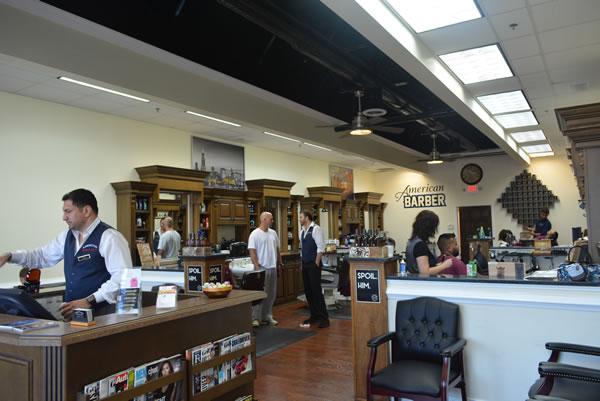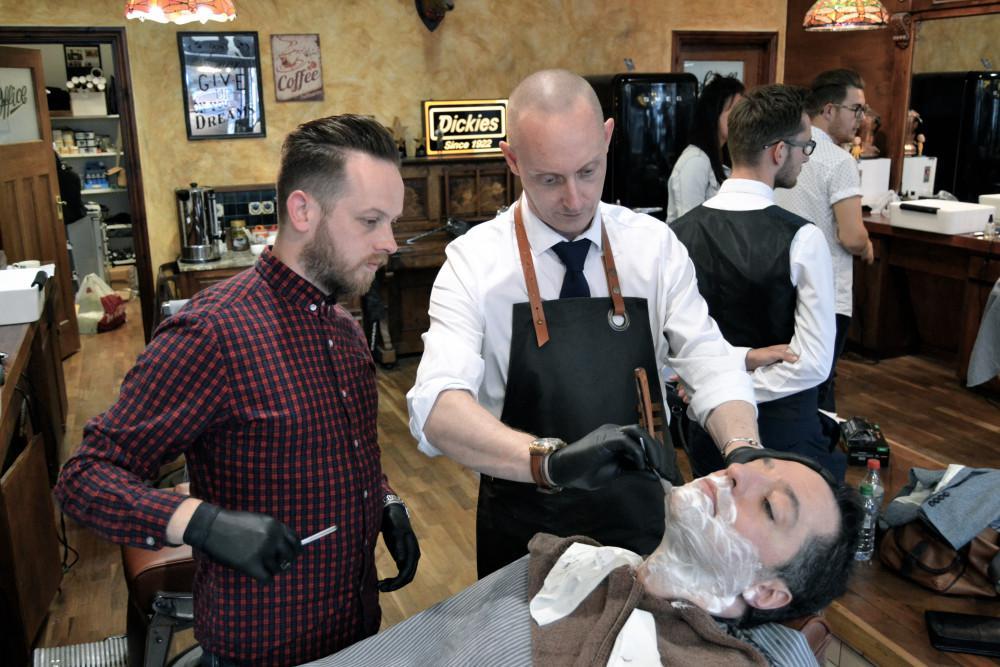The first image is the image on the left, the second image is the image on the right. Analyze the images presented: Is the assertion "There are at least three people in red capes getting there hair cut." valid? Answer yes or no. No. The first image is the image on the left, the second image is the image on the right. Evaluate the accuracy of this statement regarding the images: "Someone is at the desk in the left image.". Is it true? Answer yes or no. Yes. 